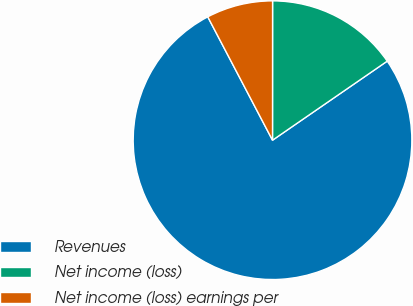Convert chart. <chart><loc_0><loc_0><loc_500><loc_500><pie_chart><fcel>Revenues<fcel>Net income (loss)<fcel>Net income (loss) earnings per<nl><fcel>76.92%<fcel>15.39%<fcel>7.7%<nl></chart> 